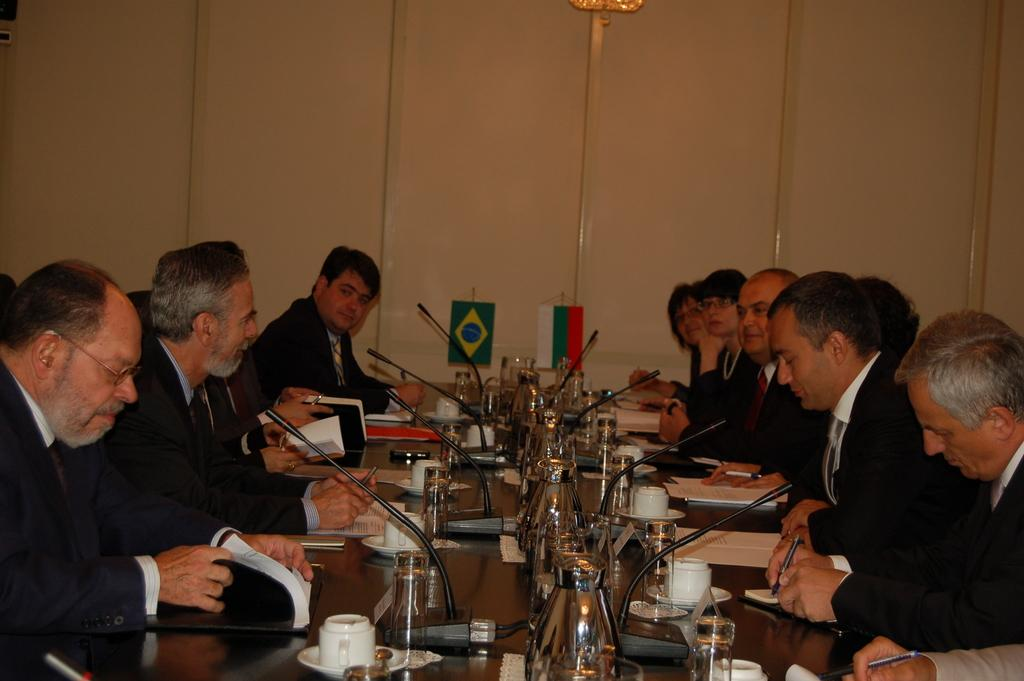What are the persons in the image wearing? The persons in the image are wearing black suits. What are the persons doing in the image? The persons are sitting in chairs. What is in front of the persons? There is a table in front of the persons. What can be seen on the table? There are microphones, cups, and other objects on the table. What type of straw is used to enhance memory in the image? There is no straw present in the image, and no mention of memory enhancement. 